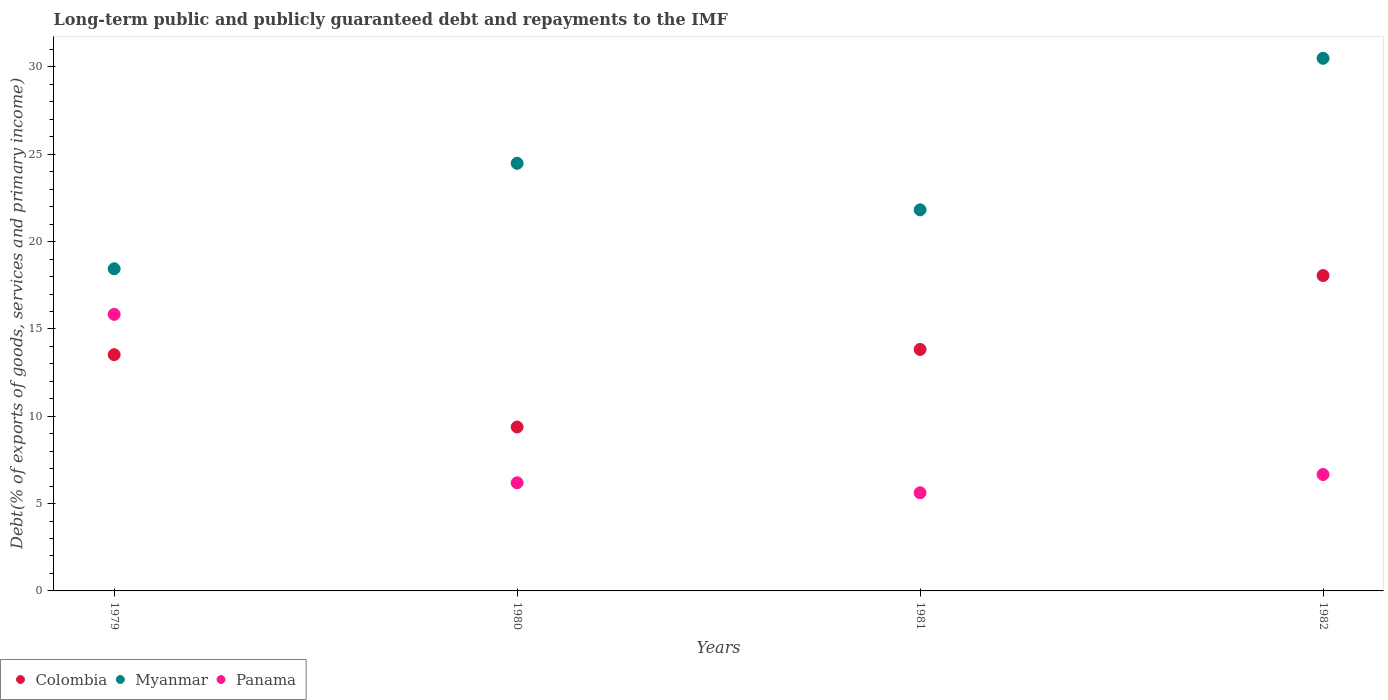What is the debt and repayments in Myanmar in 1979?
Give a very brief answer. 18.45. Across all years, what is the maximum debt and repayments in Colombia?
Your answer should be compact. 18.06. Across all years, what is the minimum debt and repayments in Colombia?
Your response must be concise. 9.39. In which year was the debt and repayments in Panama maximum?
Ensure brevity in your answer.  1979. What is the total debt and repayments in Myanmar in the graph?
Provide a succinct answer. 95.25. What is the difference between the debt and repayments in Colombia in 1980 and that in 1981?
Your answer should be very brief. -4.44. What is the difference between the debt and repayments in Panama in 1979 and the debt and repayments in Colombia in 1980?
Ensure brevity in your answer.  6.45. What is the average debt and repayments in Myanmar per year?
Your answer should be compact. 23.81. In the year 1981, what is the difference between the debt and repayments in Colombia and debt and repayments in Myanmar?
Offer a very short reply. -7.99. In how many years, is the debt and repayments in Colombia greater than 19 %?
Make the answer very short. 0. What is the ratio of the debt and repayments in Panama in 1980 to that in 1981?
Give a very brief answer. 1.1. Is the debt and repayments in Colombia in 1980 less than that in 1982?
Provide a succinct answer. Yes. Is the difference between the debt and repayments in Colombia in 1981 and 1982 greater than the difference between the debt and repayments in Myanmar in 1981 and 1982?
Keep it short and to the point. Yes. What is the difference between the highest and the second highest debt and repayments in Colombia?
Your response must be concise. 4.23. What is the difference between the highest and the lowest debt and repayments in Colombia?
Your answer should be very brief. 8.67. Is the sum of the debt and repayments in Panama in 1979 and 1982 greater than the maximum debt and repayments in Colombia across all years?
Ensure brevity in your answer.  Yes. Is it the case that in every year, the sum of the debt and repayments in Myanmar and debt and repayments in Colombia  is greater than the debt and repayments in Panama?
Keep it short and to the point. Yes. Does the debt and repayments in Myanmar monotonically increase over the years?
Offer a very short reply. No. Is the debt and repayments in Panama strictly greater than the debt and repayments in Myanmar over the years?
Offer a very short reply. No. Is the debt and repayments in Colombia strictly less than the debt and repayments in Myanmar over the years?
Your answer should be very brief. Yes. How many dotlines are there?
Provide a short and direct response. 3. How many years are there in the graph?
Offer a very short reply. 4. What is the difference between two consecutive major ticks on the Y-axis?
Your answer should be compact. 5. Does the graph contain grids?
Provide a succinct answer. No. Where does the legend appear in the graph?
Keep it short and to the point. Bottom left. How are the legend labels stacked?
Give a very brief answer. Horizontal. What is the title of the graph?
Make the answer very short. Long-term public and publicly guaranteed debt and repayments to the IMF. Does "Niger" appear as one of the legend labels in the graph?
Ensure brevity in your answer.  No. What is the label or title of the Y-axis?
Give a very brief answer. Debt(% of exports of goods, services and primary income). What is the Debt(% of exports of goods, services and primary income) in Colombia in 1979?
Keep it short and to the point. 13.53. What is the Debt(% of exports of goods, services and primary income) in Myanmar in 1979?
Make the answer very short. 18.45. What is the Debt(% of exports of goods, services and primary income) in Panama in 1979?
Provide a succinct answer. 15.84. What is the Debt(% of exports of goods, services and primary income) in Colombia in 1980?
Offer a very short reply. 9.39. What is the Debt(% of exports of goods, services and primary income) in Myanmar in 1980?
Your answer should be compact. 24.48. What is the Debt(% of exports of goods, services and primary income) in Panama in 1980?
Provide a succinct answer. 6.19. What is the Debt(% of exports of goods, services and primary income) of Colombia in 1981?
Provide a short and direct response. 13.83. What is the Debt(% of exports of goods, services and primary income) in Myanmar in 1981?
Your answer should be compact. 21.82. What is the Debt(% of exports of goods, services and primary income) of Panama in 1981?
Make the answer very short. 5.62. What is the Debt(% of exports of goods, services and primary income) of Colombia in 1982?
Offer a very short reply. 18.06. What is the Debt(% of exports of goods, services and primary income) of Myanmar in 1982?
Your response must be concise. 30.5. What is the Debt(% of exports of goods, services and primary income) in Panama in 1982?
Provide a succinct answer. 6.66. Across all years, what is the maximum Debt(% of exports of goods, services and primary income) of Colombia?
Ensure brevity in your answer.  18.06. Across all years, what is the maximum Debt(% of exports of goods, services and primary income) in Myanmar?
Provide a succinct answer. 30.5. Across all years, what is the maximum Debt(% of exports of goods, services and primary income) in Panama?
Your answer should be very brief. 15.84. Across all years, what is the minimum Debt(% of exports of goods, services and primary income) of Colombia?
Make the answer very short. 9.39. Across all years, what is the minimum Debt(% of exports of goods, services and primary income) of Myanmar?
Your answer should be very brief. 18.45. Across all years, what is the minimum Debt(% of exports of goods, services and primary income) of Panama?
Your answer should be very brief. 5.62. What is the total Debt(% of exports of goods, services and primary income) in Colombia in the graph?
Ensure brevity in your answer.  54.8. What is the total Debt(% of exports of goods, services and primary income) of Myanmar in the graph?
Give a very brief answer. 95.25. What is the total Debt(% of exports of goods, services and primary income) in Panama in the graph?
Ensure brevity in your answer.  34.31. What is the difference between the Debt(% of exports of goods, services and primary income) of Colombia in 1979 and that in 1980?
Offer a very short reply. 4.14. What is the difference between the Debt(% of exports of goods, services and primary income) of Myanmar in 1979 and that in 1980?
Keep it short and to the point. -6.04. What is the difference between the Debt(% of exports of goods, services and primary income) of Panama in 1979 and that in 1980?
Provide a succinct answer. 9.64. What is the difference between the Debt(% of exports of goods, services and primary income) of Colombia in 1979 and that in 1981?
Your answer should be very brief. -0.3. What is the difference between the Debt(% of exports of goods, services and primary income) in Myanmar in 1979 and that in 1981?
Your answer should be compact. -3.37. What is the difference between the Debt(% of exports of goods, services and primary income) of Panama in 1979 and that in 1981?
Your answer should be compact. 10.22. What is the difference between the Debt(% of exports of goods, services and primary income) in Colombia in 1979 and that in 1982?
Your answer should be compact. -4.53. What is the difference between the Debt(% of exports of goods, services and primary income) of Myanmar in 1979 and that in 1982?
Keep it short and to the point. -12.05. What is the difference between the Debt(% of exports of goods, services and primary income) in Panama in 1979 and that in 1982?
Ensure brevity in your answer.  9.17. What is the difference between the Debt(% of exports of goods, services and primary income) of Colombia in 1980 and that in 1981?
Your response must be concise. -4.44. What is the difference between the Debt(% of exports of goods, services and primary income) of Myanmar in 1980 and that in 1981?
Offer a terse response. 2.67. What is the difference between the Debt(% of exports of goods, services and primary income) of Panama in 1980 and that in 1981?
Provide a succinct answer. 0.57. What is the difference between the Debt(% of exports of goods, services and primary income) of Colombia in 1980 and that in 1982?
Provide a short and direct response. -8.67. What is the difference between the Debt(% of exports of goods, services and primary income) of Myanmar in 1980 and that in 1982?
Offer a terse response. -6.01. What is the difference between the Debt(% of exports of goods, services and primary income) in Panama in 1980 and that in 1982?
Offer a terse response. -0.47. What is the difference between the Debt(% of exports of goods, services and primary income) in Colombia in 1981 and that in 1982?
Your answer should be compact. -4.23. What is the difference between the Debt(% of exports of goods, services and primary income) of Myanmar in 1981 and that in 1982?
Offer a very short reply. -8.68. What is the difference between the Debt(% of exports of goods, services and primary income) in Panama in 1981 and that in 1982?
Keep it short and to the point. -1.05. What is the difference between the Debt(% of exports of goods, services and primary income) of Colombia in 1979 and the Debt(% of exports of goods, services and primary income) of Myanmar in 1980?
Your response must be concise. -10.96. What is the difference between the Debt(% of exports of goods, services and primary income) in Colombia in 1979 and the Debt(% of exports of goods, services and primary income) in Panama in 1980?
Give a very brief answer. 7.33. What is the difference between the Debt(% of exports of goods, services and primary income) of Myanmar in 1979 and the Debt(% of exports of goods, services and primary income) of Panama in 1980?
Offer a terse response. 12.25. What is the difference between the Debt(% of exports of goods, services and primary income) of Colombia in 1979 and the Debt(% of exports of goods, services and primary income) of Myanmar in 1981?
Make the answer very short. -8.29. What is the difference between the Debt(% of exports of goods, services and primary income) in Colombia in 1979 and the Debt(% of exports of goods, services and primary income) in Panama in 1981?
Your answer should be very brief. 7.91. What is the difference between the Debt(% of exports of goods, services and primary income) in Myanmar in 1979 and the Debt(% of exports of goods, services and primary income) in Panama in 1981?
Offer a terse response. 12.83. What is the difference between the Debt(% of exports of goods, services and primary income) of Colombia in 1979 and the Debt(% of exports of goods, services and primary income) of Myanmar in 1982?
Provide a succinct answer. -16.97. What is the difference between the Debt(% of exports of goods, services and primary income) of Colombia in 1979 and the Debt(% of exports of goods, services and primary income) of Panama in 1982?
Ensure brevity in your answer.  6.86. What is the difference between the Debt(% of exports of goods, services and primary income) of Myanmar in 1979 and the Debt(% of exports of goods, services and primary income) of Panama in 1982?
Ensure brevity in your answer.  11.78. What is the difference between the Debt(% of exports of goods, services and primary income) in Colombia in 1980 and the Debt(% of exports of goods, services and primary income) in Myanmar in 1981?
Provide a succinct answer. -12.43. What is the difference between the Debt(% of exports of goods, services and primary income) in Colombia in 1980 and the Debt(% of exports of goods, services and primary income) in Panama in 1981?
Offer a very short reply. 3.77. What is the difference between the Debt(% of exports of goods, services and primary income) in Myanmar in 1980 and the Debt(% of exports of goods, services and primary income) in Panama in 1981?
Your response must be concise. 18.87. What is the difference between the Debt(% of exports of goods, services and primary income) in Colombia in 1980 and the Debt(% of exports of goods, services and primary income) in Myanmar in 1982?
Your response must be concise. -21.11. What is the difference between the Debt(% of exports of goods, services and primary income) of Colombia in 1980 and the Debt(% of exports of goods, services and primary income) of Panama in 1982?
Offer a terse response. 2.72. What is the difference between the Debt(% of exports of goods, services and primary income) in Myanmar in 1980 and the Debt(% of exports of goods, services and primary income) in Panama in 1982?
Ensure brevity in your answer.  17.82. What is the difference between the Debt(% of exports of goods, services and primary income) of Colombia in 1981 and the Debt(% of exports of goods, services and primary income) of Myanmar in 1982?
Offer a very short reply. -16.67. What is the difference between the Debt(% of exports of goods, services and primary income) in Colombia in 1981 and the Debt(% of exports of goods, services and primary income) in Panama in 1982?
Your response must be concise. 7.16. What is the difference between the Debt(% of exports of goods, services and primary income) of Myanmar in 1981 and the Debt(% of exports of goods, services and primary income) of Panama in 1982?
Make the answer very short. 15.16. What is the average Debt(% of exports of goods, services and primary income) of Colombia per year?
Give a very brief answer. 13.7. What is the average Debt(% of exports of goods, services and primary income) of Myanmar per year?
Provide a short and direct response. 23.81. What is the average Debt(% of exports of goods, services and primary income) in Panama per year?
Provide a succinct answer. 8.58. In the year 1979, what is the difference between the Debt(% of exports of goods, services and primary income) of Colombia and Debt(% of exports of goods, services and primary income) of Myanmar?
Your answer should be very brief. -4.92. In the year 1979, what is the difference between the Debt(% of exports of goods, services and primary income) of Colombia and Debt(% of exports of goods, services and primary income) of Panama?
Keep it short and to the point. -2.31. In the year 1979, what is the difference between the Debt(% of exports of goods, services and primary income) in Myanmar and Debt(% of exports of goods, services and primary income) in Panama?
Provide a short and direct response. 2.61. In the year 1980, what is the difference between the Debt(% of exports of goods, services and primary income) in Colombia and Debt(% of exports of goods, services and primary income) in Myanmar?
Make the answer very short. -15.1. In the year 1980, what is the difference between the Debt(% of exports of goods, services and primary income) in Colombia and Debt(% of exports of goods, services and primary income) in Panama?
Make the answer very short. 3.19. In the year 1980, what is the difference between the Debt(% of exports of goods, services and primary income) in Myanmar and Debt(% of exports of goods, services and primary income) in Panama?
Make the answer very short. 18.29. In the year 1981, what is the difference between the Debt(% of exports of goods, services and primary income) of Colombia and Debt(% of exports of goods, services and primary income) of Myanmar?
Make the answer very short. -7.99. In the year 1981, what is the difference between the Debt(% of exports of goods, services and primary income) of Colombia and Debt(% of exports of goods, services and primary income) of Panama?
Your answer should be very brief. 8.21. In the year 1981, what is the difference between the Debt(% of exports of goods, services and primary income) in Myanmar and Debt(% of exports of goods, services and primary income) in Panama?
Provide a short and direct response. 16.2. In the year 1982, what is the difference between the Debt(% of exports of goods, services and primary income) in Colombia and Debt(% of exports of goods, services and primary income) in Myanmar?
Make the answer very short. -12.44. In the year 1982, what is the difference between the Debt(% of exports of goods, services and primary income) of Colombia and Debt(% of exports of goods, services and primary income) of Panama?
Ensure brevity in your answer.  11.39. In the year 1982, what is the difference between the Debt(% of exports of goods, services and primary income) in Myanmar and Debt(% of exports of goods, services and primary income) in Panama?
Provide a succinct answer. 23.83. What is the ratio of the Debt(% of exports of goods, services and primary income) in Colombia in 1979 to that in 1980?
Offer a terse response. 1.44. What is the ratio of the Debt(% of exports of goods, services and primary income) of Myanmar in 1979 to that in 1980?
Keep it short and to the point. 0.75. What is the ratio of the Debt(% of exports of goods, services and primary income) in Panama in 1979 to that in 1980?
Make the answer very short. 2.56. What is the ratio of the Debt(% of exports of goods, services and primary income) of Colombia in 1979 to that in 1981?
Give a very brief answer. 0.98. What is the ratio of the Debt(% of exports of goods, services and primary income) of Myanmar in 1979 to that in 1981?
Offer a very short reply. 0.85. What is the ratio of the Debt(% of exports of goods, services and primary income) in Panama in 1979 to that in 1981?
Provide a short and direct response. 2.82. What is the ratio of the Debt(% of exports of goods, services and primary income) of Colombia in 1979 to that in 1982?
Offer a very short reply. 0.75. What is the ratio of the Debt(% of exports of goods, services and primary income) of Myanmar in 1979 to that in 1982?
Your answer should be very brief. 0.6. What is the ratio of the Debt(% of exports of goods, services and primary income) in Panama in 1979 to that in 1982?
Keep it short and to the point. 2.38. What is the ratio of the Debt(% of exports of goods, services and primary income) in Colombia in 1980 to that in 1981?
Offer a terse response. 0.68. What is the ratio of the Debt(% of exports of goods, services and primary income) of Myanmar in 1980 to that in 1981?
Keep it short and to the point. 1.12. What is the ratio of the Debt(% of exports of goods, services and primary income) of Panama in 1980 to that in 1981?
Make the answer very short. 1.1. What is the ratio of the Debt(% of exports of goods, services and primary income) in Colombia in 1980 to that in 1982?
Your response must be concise. 0.52. What is the ratio of the Debt(% of exports of goods, services and primary income) in Myanmar in 1980 to that in 1982?
Provide a short and direct response. 0.8. What is the ratio of the Debt(% of exports of goods, services and primary income) of Panama in 1980 to that in 1982?
Make the answer very short. 0.93. What is the ratio of the Debt(% of exports of goods, services and primary income) in Colombia in 1981 to that in 1982?
Keep it short and to the point. 0.77. What is the ratio of the Debt(% of exports of goods, services and primary income) of Myanmar in 1981 to that in 1982?
Your answer should be compact. 0.72. What is the ratio of the Debt(% of exports of goods, services and primary income) of Panama in 1981 to that in 1982?
Provide a succinct answer. 0.84. What is the difference between the highest and the second highest Debt(% of exports of goods, services and primary income) of Colombia?
Provide a short and direct response. 4.23. What is the difference between the highest and the second highest Debt(% of exports of goods, services and primary income) of Myanmar?
Offer a very short reply. 6.01. What is the difference between the highest and the second highest Debt(% of exports of goods, services and primary income) of Panama?
Your answer should be very brief. 9.17. What is the difference between the highest and the lowest Debt(% of exports of goods, services and primary income) in Colombia?
Your answer should be very brief. 8.67. What is the difference between the highest and the lowest Debt(% of exports of goods, services and primary income) in Myanmar?
Your answer should be compact. 12.05. What is the difference between the highest and the lowest Debt(% of exports of goods, services and primary income) of Panama?
Provide a short and direct response. 10.22. 